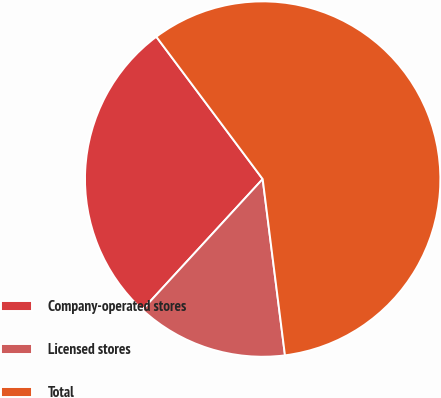Convert chart to OTSL. <chart><loc_0><loc_0><loc_500><loc_500><pie_chart><fcel>Company-operated stores<fcel>Licensed stores<fcel>Total<nl><fcel>27.95%<fcel>13.84%<fcel>58.21%<nl></chart> 